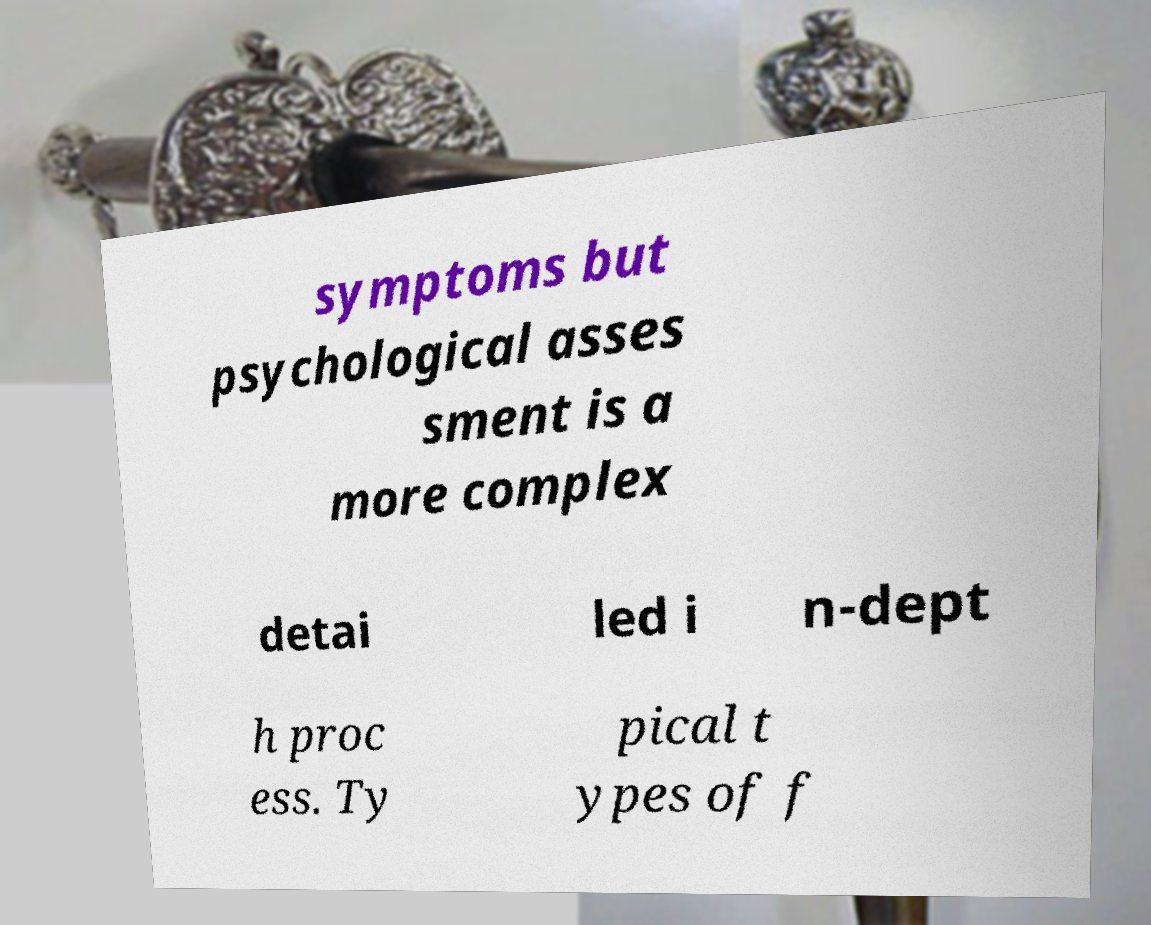There's text embedded in this image that I need extracted. Can you transcribe it verbatim? symptoms but psychological asses sment is a more complex detai led i n-dept h proc ess. Ty pical t ypes of f 